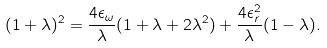<formula> <loc_0><loc_0><loc_500><loc_500>( 1 + \lambda ) ^ { 2 } = \frac { 4 \epsilon _ { \omega } } { \lambda } ( 1 + \lambda + 2 \lambda ^ { 2 } ) + \frac { 4 \epsilon _ { r } ^ { 2 } } { \lambda } ( 1 - \lambda ) .</formula> 